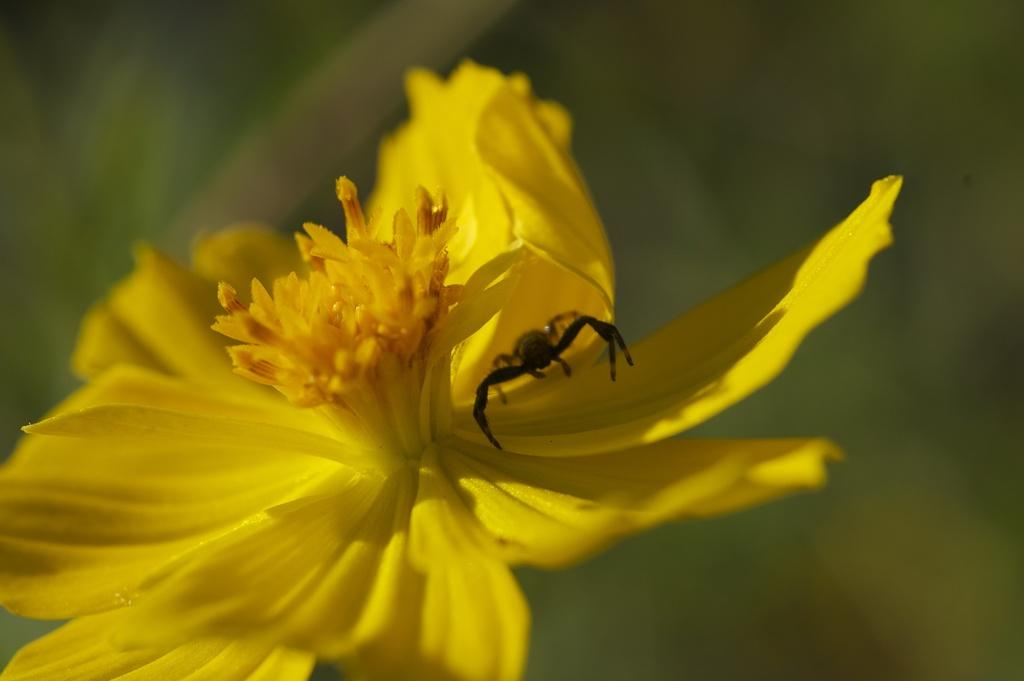What is the main subject of the image? There is a beautiful flower in the image. Is there anything else present on the flower? Yes, there is an insect on the flower. What type of ring is the insect wearing on its thumb in the image? There is no ring or thumb present in the image, as it features a flower with an insect on it. 